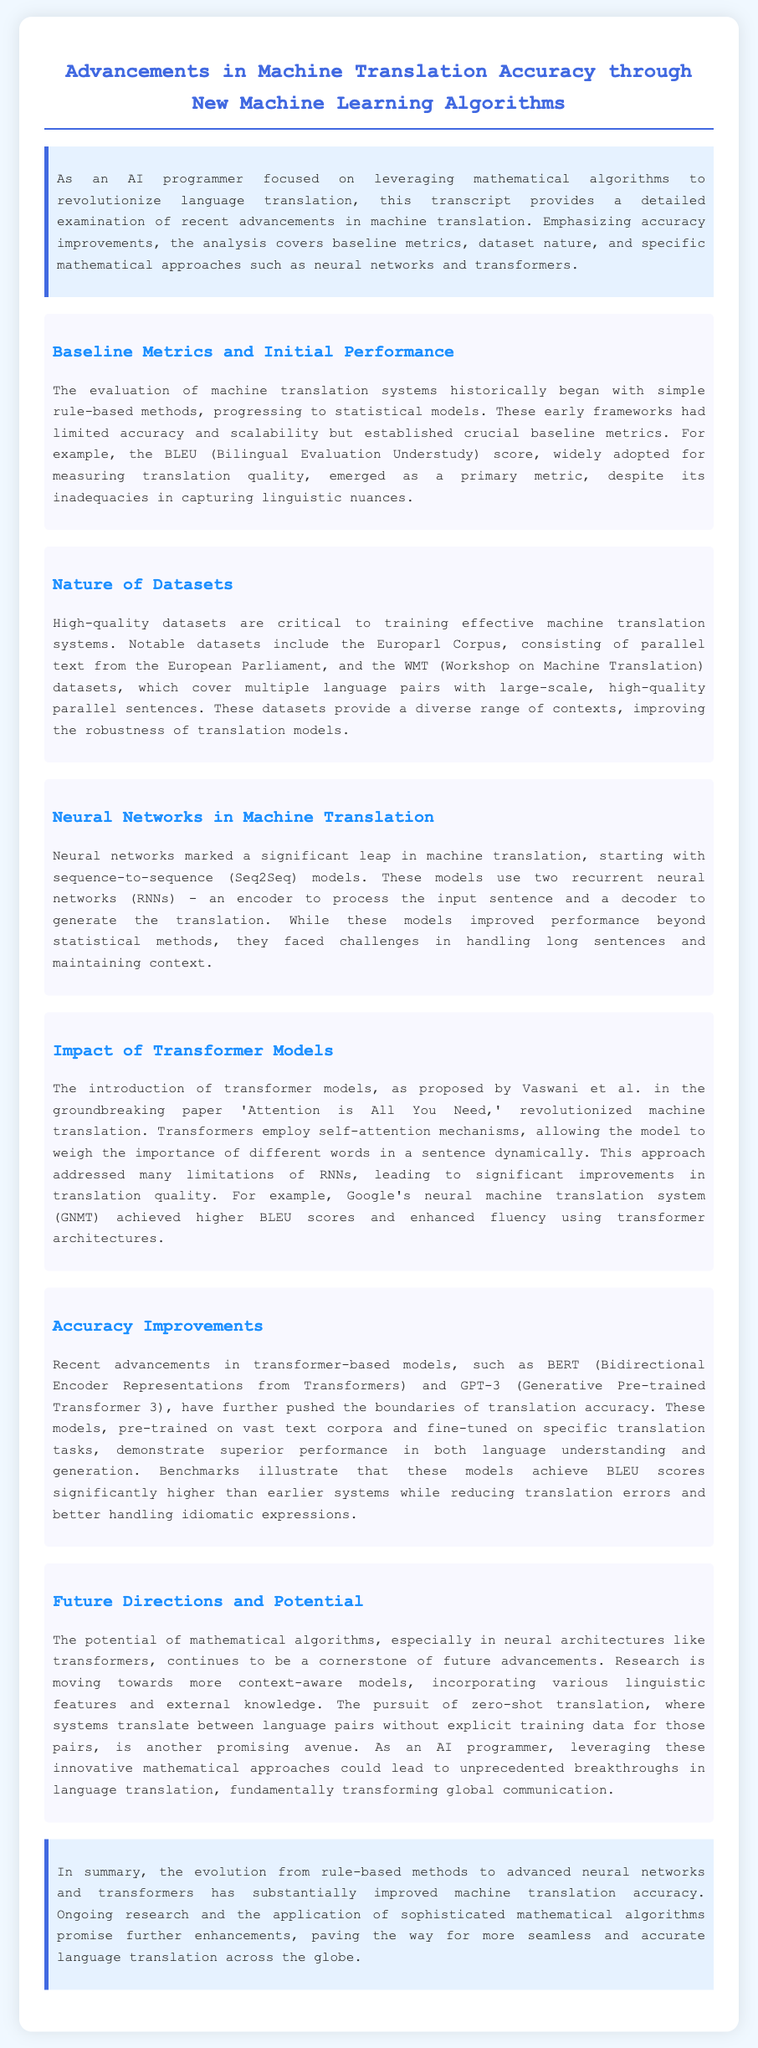What is the primary metric for measuring translation quality? The document states that BLEU (Bilingual Evaluation Understudy) score is the primary metric for measuring translation quality.
Answer: BLEU What two types of models are mentioned that use recurring neural networks? The section states that sequence-to-sequence models use two recurrent neural networks (RNNs), an encoder and a decoder.
Answer: Encoder and decoder What is the title of the paper that introduced transformer models? The document cites 'Attention is All You Need' as the title of the paper that introduced transformer models.
Answer: Attention is All You Need Which two advanced models are mentioned in the context of accuracy improvements? The document mentions BERT and GPT-3 as advanced models that have pushed the boundaries of translation accuracy.
Answer: BERT and GPT-3 What does the acronym GNMT stand for? The document describes Google's neural machine translation system, which is abbreviated as GNMT.
Answer: GNMT What kind of improvements do transformers achieve in translation quality? The text asserts that transformers lead to significant improvements in translation quality, addressing limitations of RNNs.
Answer: Significant improvements What type of model does "zero-shot translation" refer to? Zero-shot translation refers to systems that translate between language pairs without explicit training data for those pairs.
Answer: Systems that translate without explicit training data In which section is the introduction of high-quality datasets discussed? The section titled "Nature of Datasets" discusses the introduction of high-quality datasets.
Answer: Nature of Datasets What is the background color of the intro section? The intro section has a background color of light blue indicated by the hex code #e6f2ff.
Answer: Light blue 